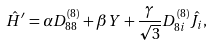<formula> <loc_0><loc_0><loc_500><loc_500>\hat { H } ^ { \prime } = \alpha D _ { 8 8 } ^ { ( 8 ) } + \beta Y + \frac { \gamma } { \sqrt { 3 } } D _ { 8 i } ^ { ( 8 ) } \hat { J } _ { i } ,</formula> 